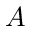<formula> <loc_0><loc_0><loc_500><loc_500>A</formula> 